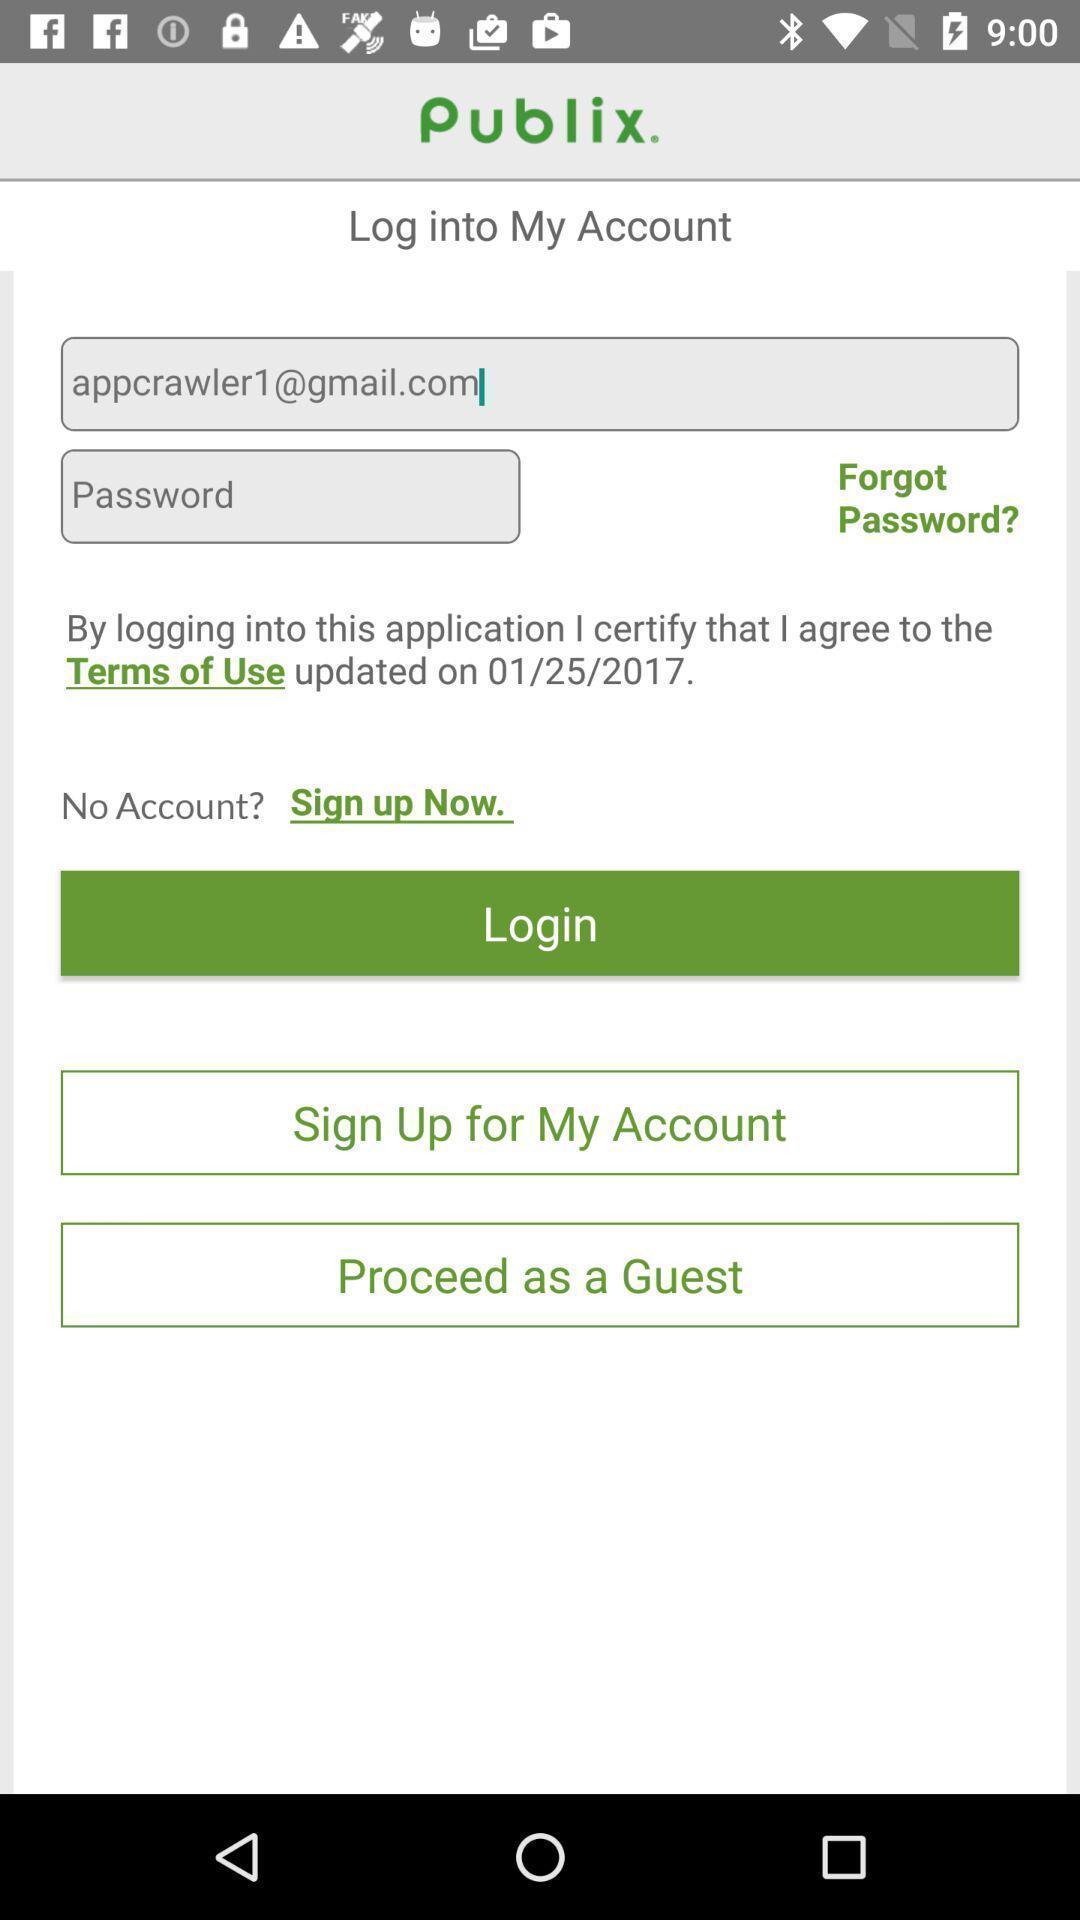Give me a narrative description of this picture. Welcome page of a shopping app. 